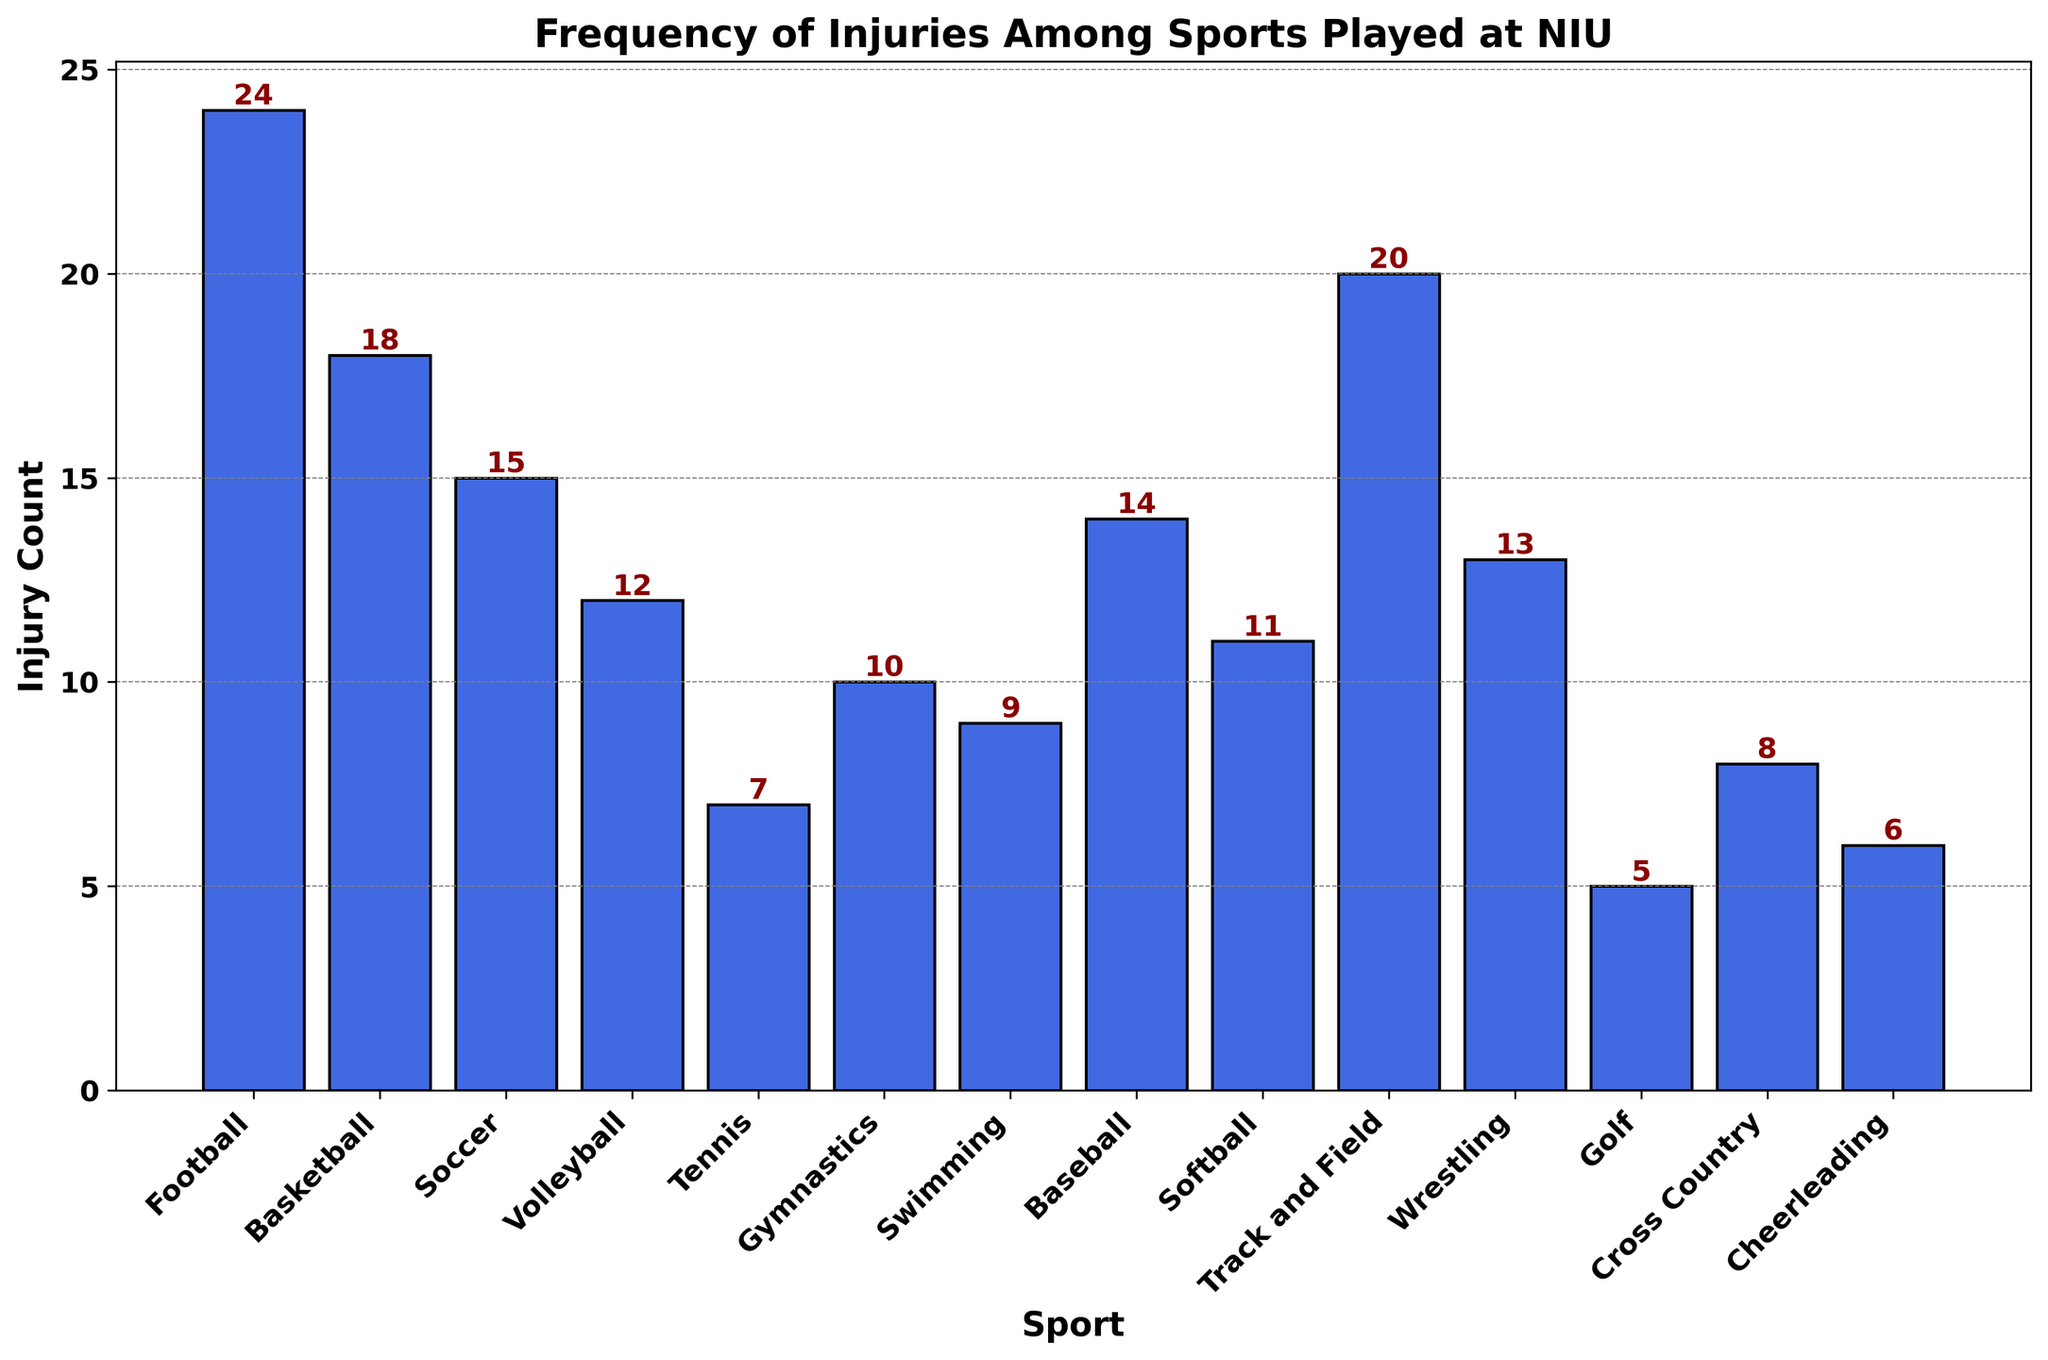What's the sport with the highest injury count? Look at the height of the bars and identify the tallest one, which represents the highest injury count. The tallest bar belongs to Football.
Answer: Football Which sport has fewer injuries: Tennis or Gymnastics? Compare the heights of the bars for Tennis and Gymnastics. The Tennis bar is shorter with 7 injuries, while Gymnastics has 10.
Answer: Tennis What is the total number of injuries for Football, Basketball, and Soccer? Sum the injury counts for Football (24), Basketball (18), and Soccer (15). 24 + 18 + 15 = 57
Answer: 57 Which sport has exactly 12 injuries? Look at the bar heights and the numbers on top of the bars, identify the one with 12 injuries. That sport is Volleyball.
Answer: Volleyball How many sports have more than 10 injuries? Count the bars with heights indicating they have >10 injuries. The sports are Football, Basketball, Soccer, Volleyball, Track and Field, Wrestling, and Baseball. Totaling to 7 sports.
Answer: 7 Is the injury count for Baseball greater than for Track and Field? Compare the heights of the bars for Baseball and Track and Field. Track and Field has 20 injuries, and Baseball has 14. Thus, Track and Field has more injuries.
Answer: No What is the median injury count across all sports? Sort the injury counts and find the middle value. Sorted counts: 5, 6, 7, 8, 9, 10, 11, 12, 13, 14, 15, 18, 20, 24. Median is the average of the 7th and 8th values: (10+11)/2 = 10.5
Answer: 10.5 Which sports have the injury counts close to the average? Calculate the average injury count first: (24+18+15+12+7+10+9+14+11+20+13+5+8+6)/14 ≈ 11.64. Then look for sports around this value. Baseball (14), Softball (11), Wrestling (13), and Volleyball (12) are close.
Answer: Baseball, Softball, Wrestling, Volleyball Which sport has the least number of injuries? Find the bar with the smallest height, indicating the fewest injuries. The shortest bar belongs to Golf, with 5 injuries.
Answer: Golf 